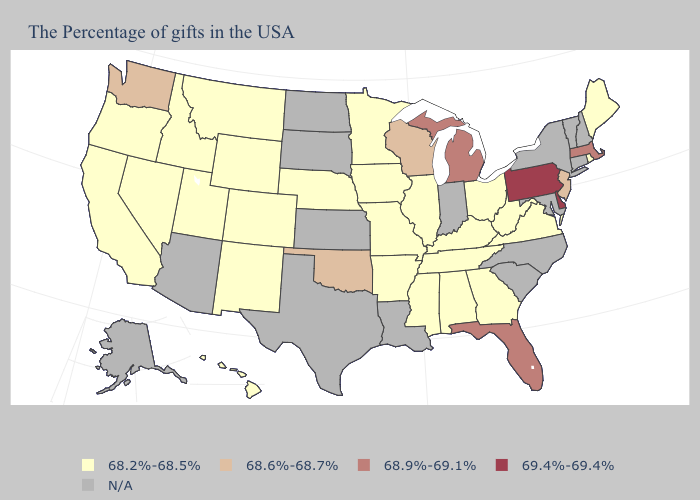What is the value of Nebraska?
Keep it brief. 68.2%-68.5%. What is the value of Delaware?
Concise answer only. 69.4%-69.4%. What is the highest value in the South ?
Be succinct. 69.4%-69.4%. Does Delaware have the highest value in the South?
Concise answer only. Yes. Does Washington have the highest value in the USA?
Write a very short answer. No. Among the states that border Georgia , which have the highest value?
Keep it brief. Florida. What is the value of North Carolina?
Concise answer only. N/A. What is the lowest value in states that border Tennessee?
Answer briefly. 68.2%-68.5%. Does Washington have the lowest value in the West?
Write a very short answer. No. What is the lowest value in states that border Rhode Island?
Answer briefly. 68.9%-69.1%. Name the states that have a value in the range 69.4%-69.4%?
Give a very brief answer. Delaware, Pennsylvania. 